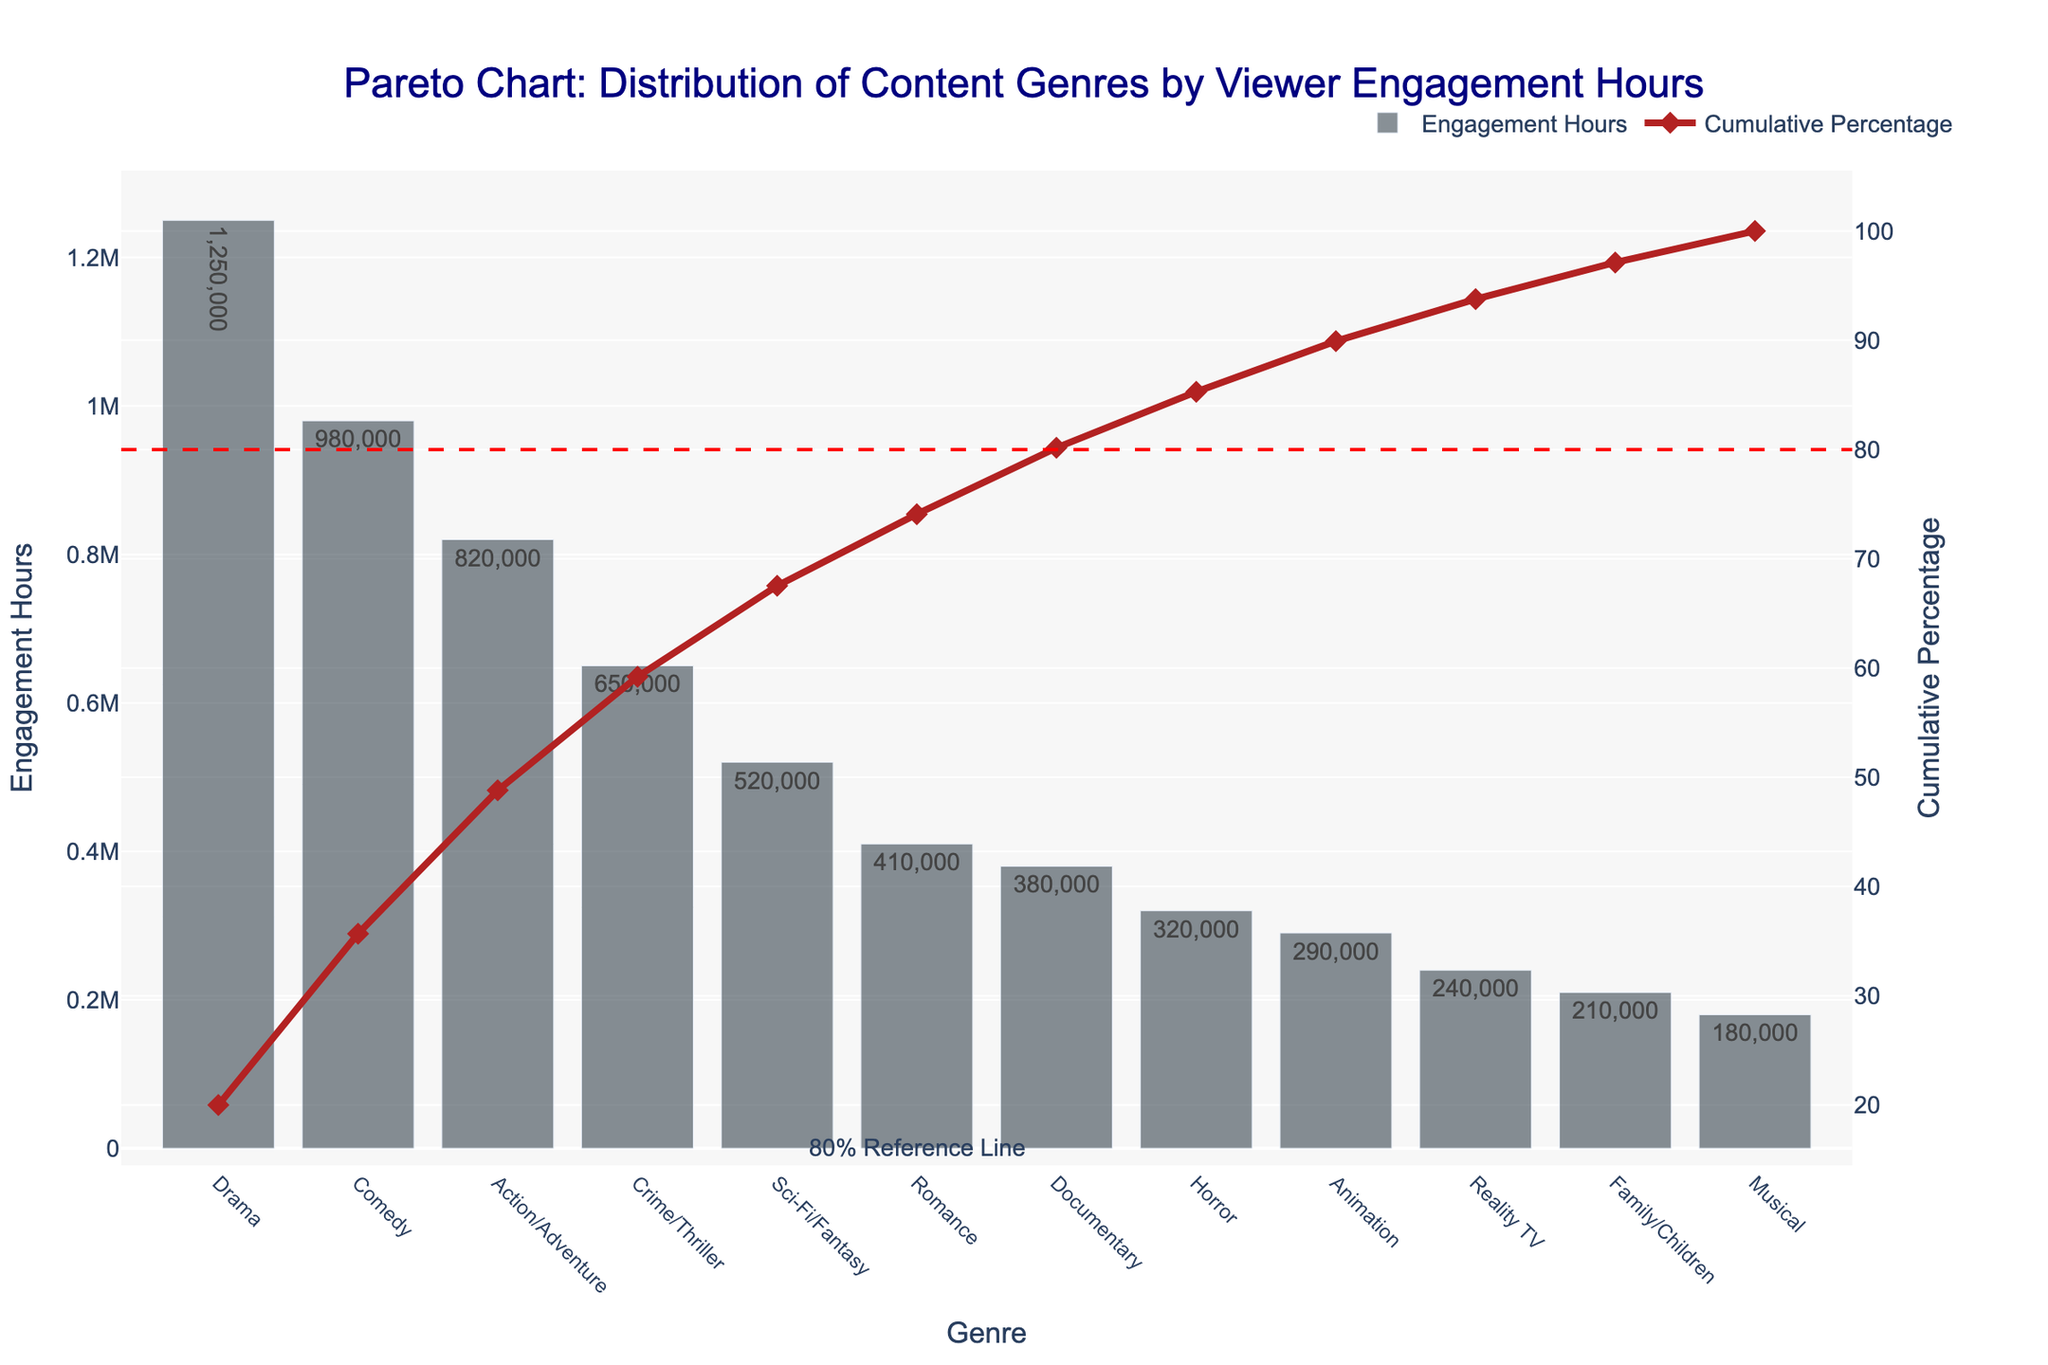What genre has the highest viewer engagement hours? The title and y-axis of the Pareto chart show the distribution of content genres by viewer engagement hours. The genre with the highest bar represents the one with the most engagement hours.
Answer: Drama How many genres contribute to over 80% of the cumulative viewer engagement hours? Refer to the cumulative percentage line and the 80% reference line in the Pareto chart. Count the number of genres up to where the cumulative percentage line intersects the 80% mark.
Answer: 5 What is the cumulative percentage of viewer engagement hours after the first 4 genres? Identify the cumulative percentage line level after the fourth genre on the x-axis. Refer to the corresponding value on the secondary y-axis.
Answer: Approximately 78% Which genre has the least viewer engagement hours? The genre with the smallest bar on the chart indicates the least engagement hours.
Answer: Musical How many genres have more than 500,000 engagement hours? Count the number of bars whose values exceed 500,000 on the primary y-axis.
Answer: 4 What is the cumulative percentage for Comedy? Find the cumulative percentage value on the secondary y-axis that aligns with the Comedy genre on the x-axis.
Answer: Approximately 47% How many genres have a cumulative percentage less than 50%? Determine where the cumulative percentage line crosses the 50% mark and count the genres up to that point on the x-axis.
Answer: 2 Compare the engagement hours of Action/Adventure and Documentary genres. Which one has more? Look at the height of the bars for Action/Adventure and Documentary on the y-axis to see which one is taller.
Answer: Action/Adventure What is the total engagement hours for the top 3 genres combined? Sum the engagement hours for Drama, Comedy, and Action/Adventure, as seen on the y-axis. 1250000 + 980000 + 820000 = 3050000
Answer: 3,050,000 What percentage of viewer engagement hours does Romance genre contribute? Divide the engagement hours of Romance by the total sum of all engagement hours and multiply by 100. (410,000 / 6,620,000) * 100 ≈ 6.19%
Answer: Approximately 6.19% 